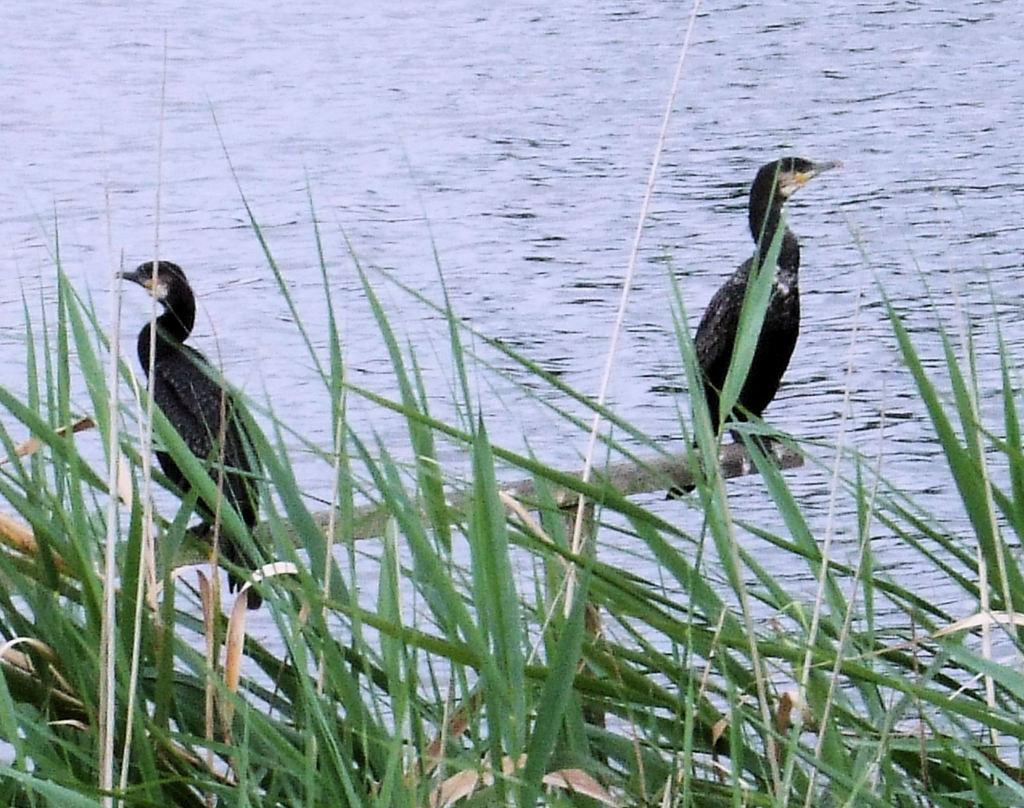What type of animals can be seen in the image? There are two black color birds in the image. Where are the birds located? The birds are on a wooden pole. What is the terrain like in the image? There is grass on the land in the image. What can be seen in the distance in the image? There is a river visible in the background of the image. What language is the grandfather speaking to the birds in the image? There is no grandfather or spoken language present in the image. The birds are simply perched on a wooden pole. 